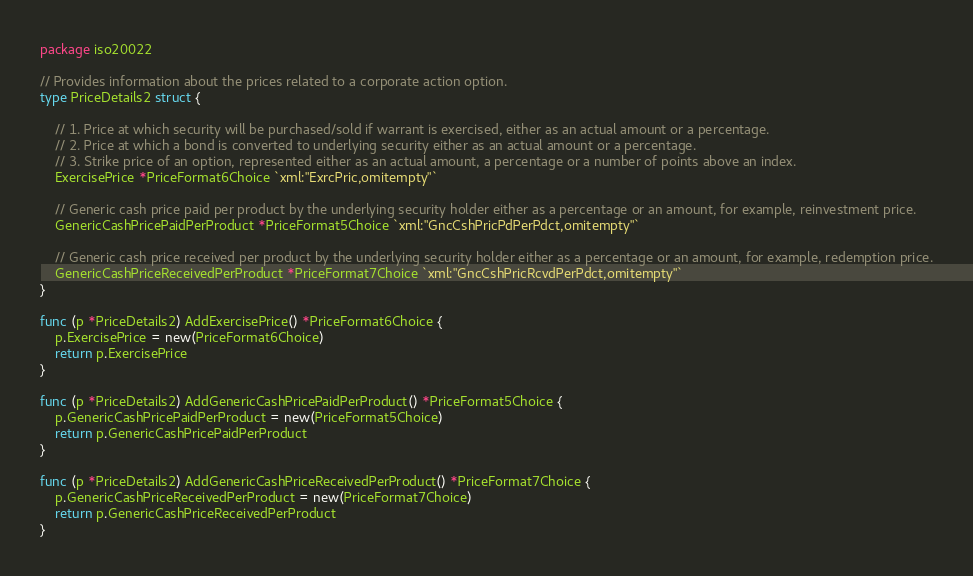<code> <loc_0><loc_0><loc_500><loc_500><_Go_>package iso20022

// Provides information about the prices related to a corporate action option.
type PriceDetails2 struct {

	// 1. Price at which security will be purchased/sold if warrant is exercised, either as an actual amount or a percentage.
	// 2. Price at which a bond is converted to underlying security either as an actual amount or a percentage.
	// 3. Strike price of an option, represented either as an actual amount, a percentage or a number of points above an index.
	ExercisePrice *PriceFormat6Choice `xml:"ExrcPric,omitempty"`

	// Generic cash price paid per product by the underlying security holder either as a percentage or an amount, for example, reinvestment price.
	GenericCashPricePaidPerProduct *PriceFormat5Choice `xml:"GncCshPricPdPerPdct,omitempty"`

	// Generic cash price received per product by the underlying security holder either as a percentage or an amount, for example, redemption price.
	GenericCashPriceReceivedPerProduct *PriceFormat7Choice `xml:"GncCshPricRcvdPerPdct,omitempty"`
}

func (p *PriceDetails2) AddExercisePrice() *PriceFormat6Choice {
	p.ExercisePrice = new(PriceFormat6Choice)
	return p.ExercisePrice
}

func (p *PriceDetails2) AddGenericCashPricePaidPerProduct() *PriceFormat5Choice {
	p.GenericCashPricePaidPerProduct = new(PriceFormat5Choice)
	return p.GenericCashPricePaidPerProduct
}

func (p *PriceDetails2) AddGenericCashPriceReceivedPerProduct() *PriceFormat7Choice {
	p.GenericCashPriceReceivedPerProduct = new(PriceFormat7Choice)
	return p.GenericCashPriceReceivedPerProduct
}
</code> 